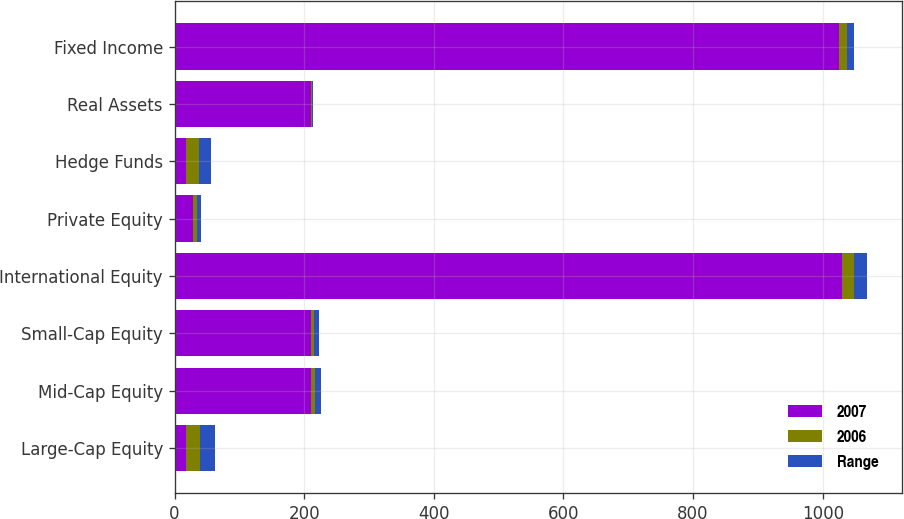<chart> <loc_0><loc_0><loc_500><loc_500><stacked_bar_chart><ecel><fcel>Large-Cap Equity<fcel>Mid-Cap Equity<fcel>Small-Cap Equity<fcel>International Equity<fcel>Private Equity<fcel>Hedge Funds<fcel>Real Assets<fcel>Fixed Income<nl><fcel>2007<fcel>18.3<fcel>210<fcel>210<fcel>1030<fcel>28<fcel>18.3<fcel>210<fcel>1025<nl><fcel>2006<fcel>20.6<fcel>7.3<fcel>5.8<fcel>17.5<fcel>6.2<fcel>19.4<fcel>1.7<fcel>12.3<nl><fcel>Range<fcel>23.3<fcel>8<fcel>6.7<fcel>20.7<fcel>6.4<fcel>19.1<fcel>2.5<fcel>11.4<nl></chart> 